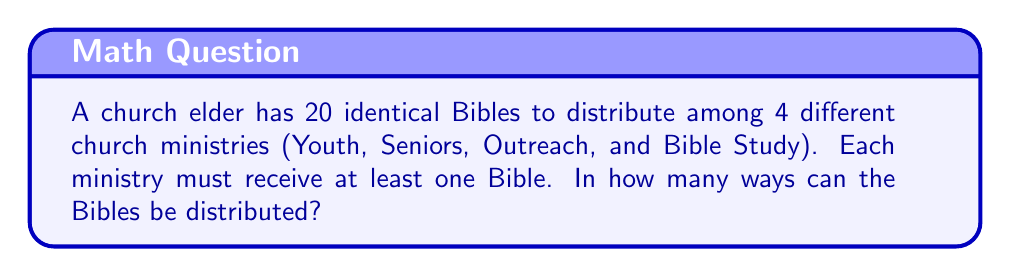Solve this math problem. Let's approach this step-by-step:

1) This is a classic stars and bars problem. We need to distribute 20 identical objects (Bibles) into 4 distinct groups (ministries).

2) However, each ministry must receive at least one Bible. To account for this, we can first give each ministry one Bible, and then distribute the remaining Bibles.

3) After giving one Bible to each ministry, we have 20 - 4 = 16 Bibles left to distribute.

4) Now, we need to find the number of ways to distribute 16 identical objects into 4 distinct groups, with no restrictions on the number each group can receive.

5) The formula for this is:

   $$\binom{n+k-1}{k-1}$$

   where n is the number of identical objects and k is the number of distinct groups.

6) In our case, n = 16 and k = 4. So we need to calculate:

   $$\binom{16+4-1}{4-1} = \binom{19}{3}$$

7) We can calculate this as:

   $$\binom{19}{3} = \frac{19!}{3!(19-3)!} = \frac{19!}{3!16!} = \frac{19 \cdot 18 \cdot 17}{3 \cdot 2 \cdot 1} = 969$$

Therefore, there are 969 ways to distribute the Bibles among the ministries.
Answer: 969 